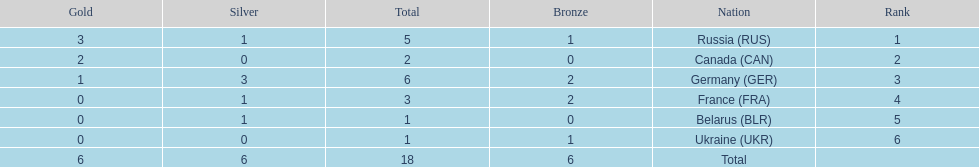What country had the most medals total at the the 1994 winter olympics biathlon? Germany (GER). Would you mind parsing the complete table? {'header': ['Gold', 'Silver', 'Total', 'Bronze', 'Nation', 'Rank'], 'rows': [['3', '1', '5', '1', 'Russia\xa0(RUS)', '1'], ['2', '0', '2', '0', 'Canada\xa0(CAN)', '2'], ['1', '3', '6', '2', 'Germany\xa0(GER)', '3'], ['0', '1', '3', '2', 'France\xa0(FRA)', '4'], ['0', '1', '1', '0', 'Belarus\xa0(BLR)', '5'], ['0', '0', '1', '1', 'Ukraine\xa0(UKR)', '6'], ['6', '6', '18', '6', 'Total', '']]} 